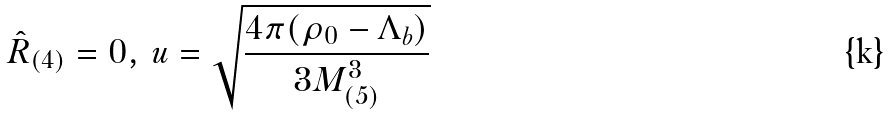Convert formula to latex. <formula><loc_0><loc_0><loc_500><loc_500>\hat { R } _ { ( 4 ) } = 0 , \, u = \sqrt { \frac { 4 \pi ( \rho _ { 0 } - \Lambda _ { b } ) } { 3 M _ { ( 5 ) } ^ { 3 } } }</formula> 